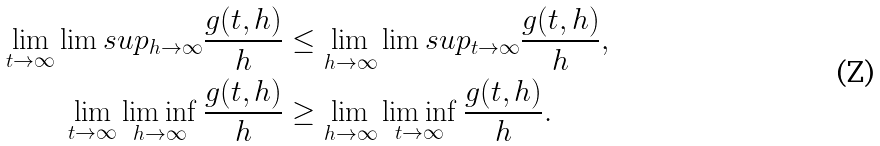Convert formula to latex. <formula><loc_0><loc_0><loc_500><loc_500>\lim _ { t \to \infty } \lim s u p _ { h \to \infty } \frac { g ( t , h ) } { h } & \leq \lim _ { h \to \infty } \lim s u p _ { t \to \infty } \frac { g ( t , h ) } { h } , \\ \lim _ { t \to \infty } \liminf _ { h \to \infty } \frac { g ( t , h ) } { h } & \geq \lim _ { h \to \infty } \liminf _ { t \to \infty } \frac { g ( t , h ) } { h } .</formula> 